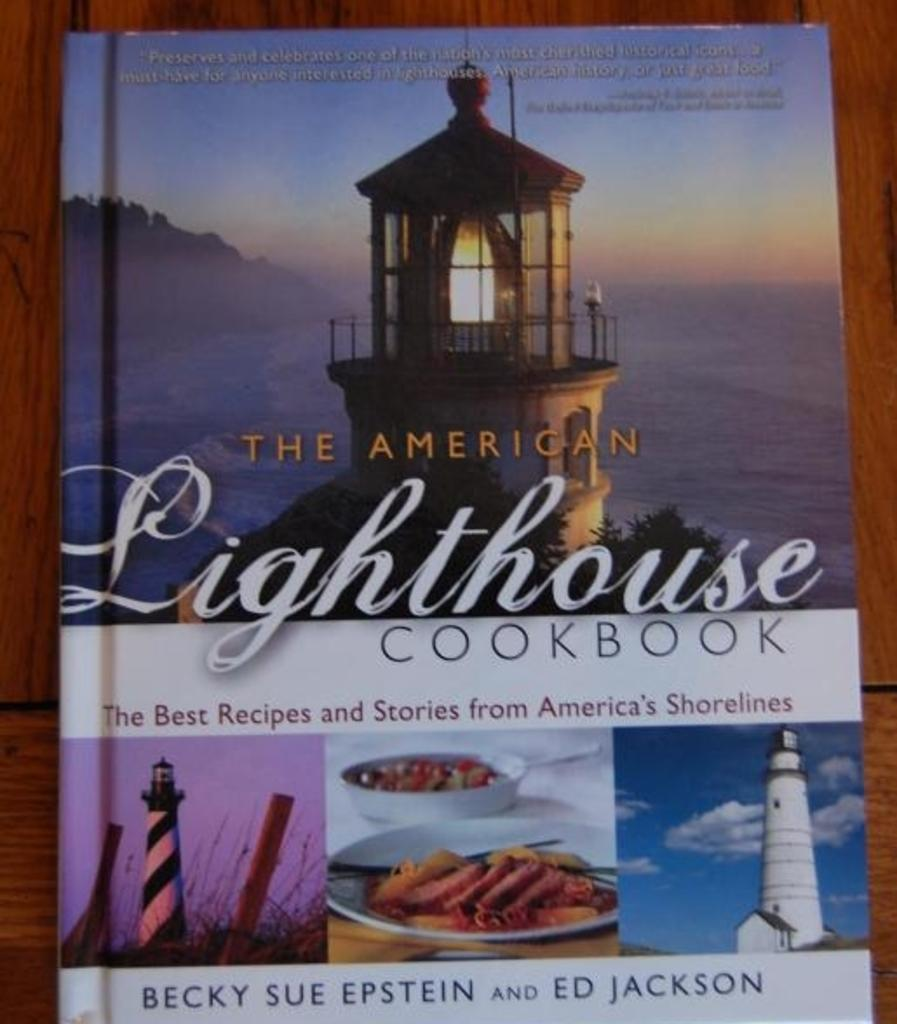<image>
Describe the image concisely. A copy of The American Lighthouse Cookbook lays on a table. 